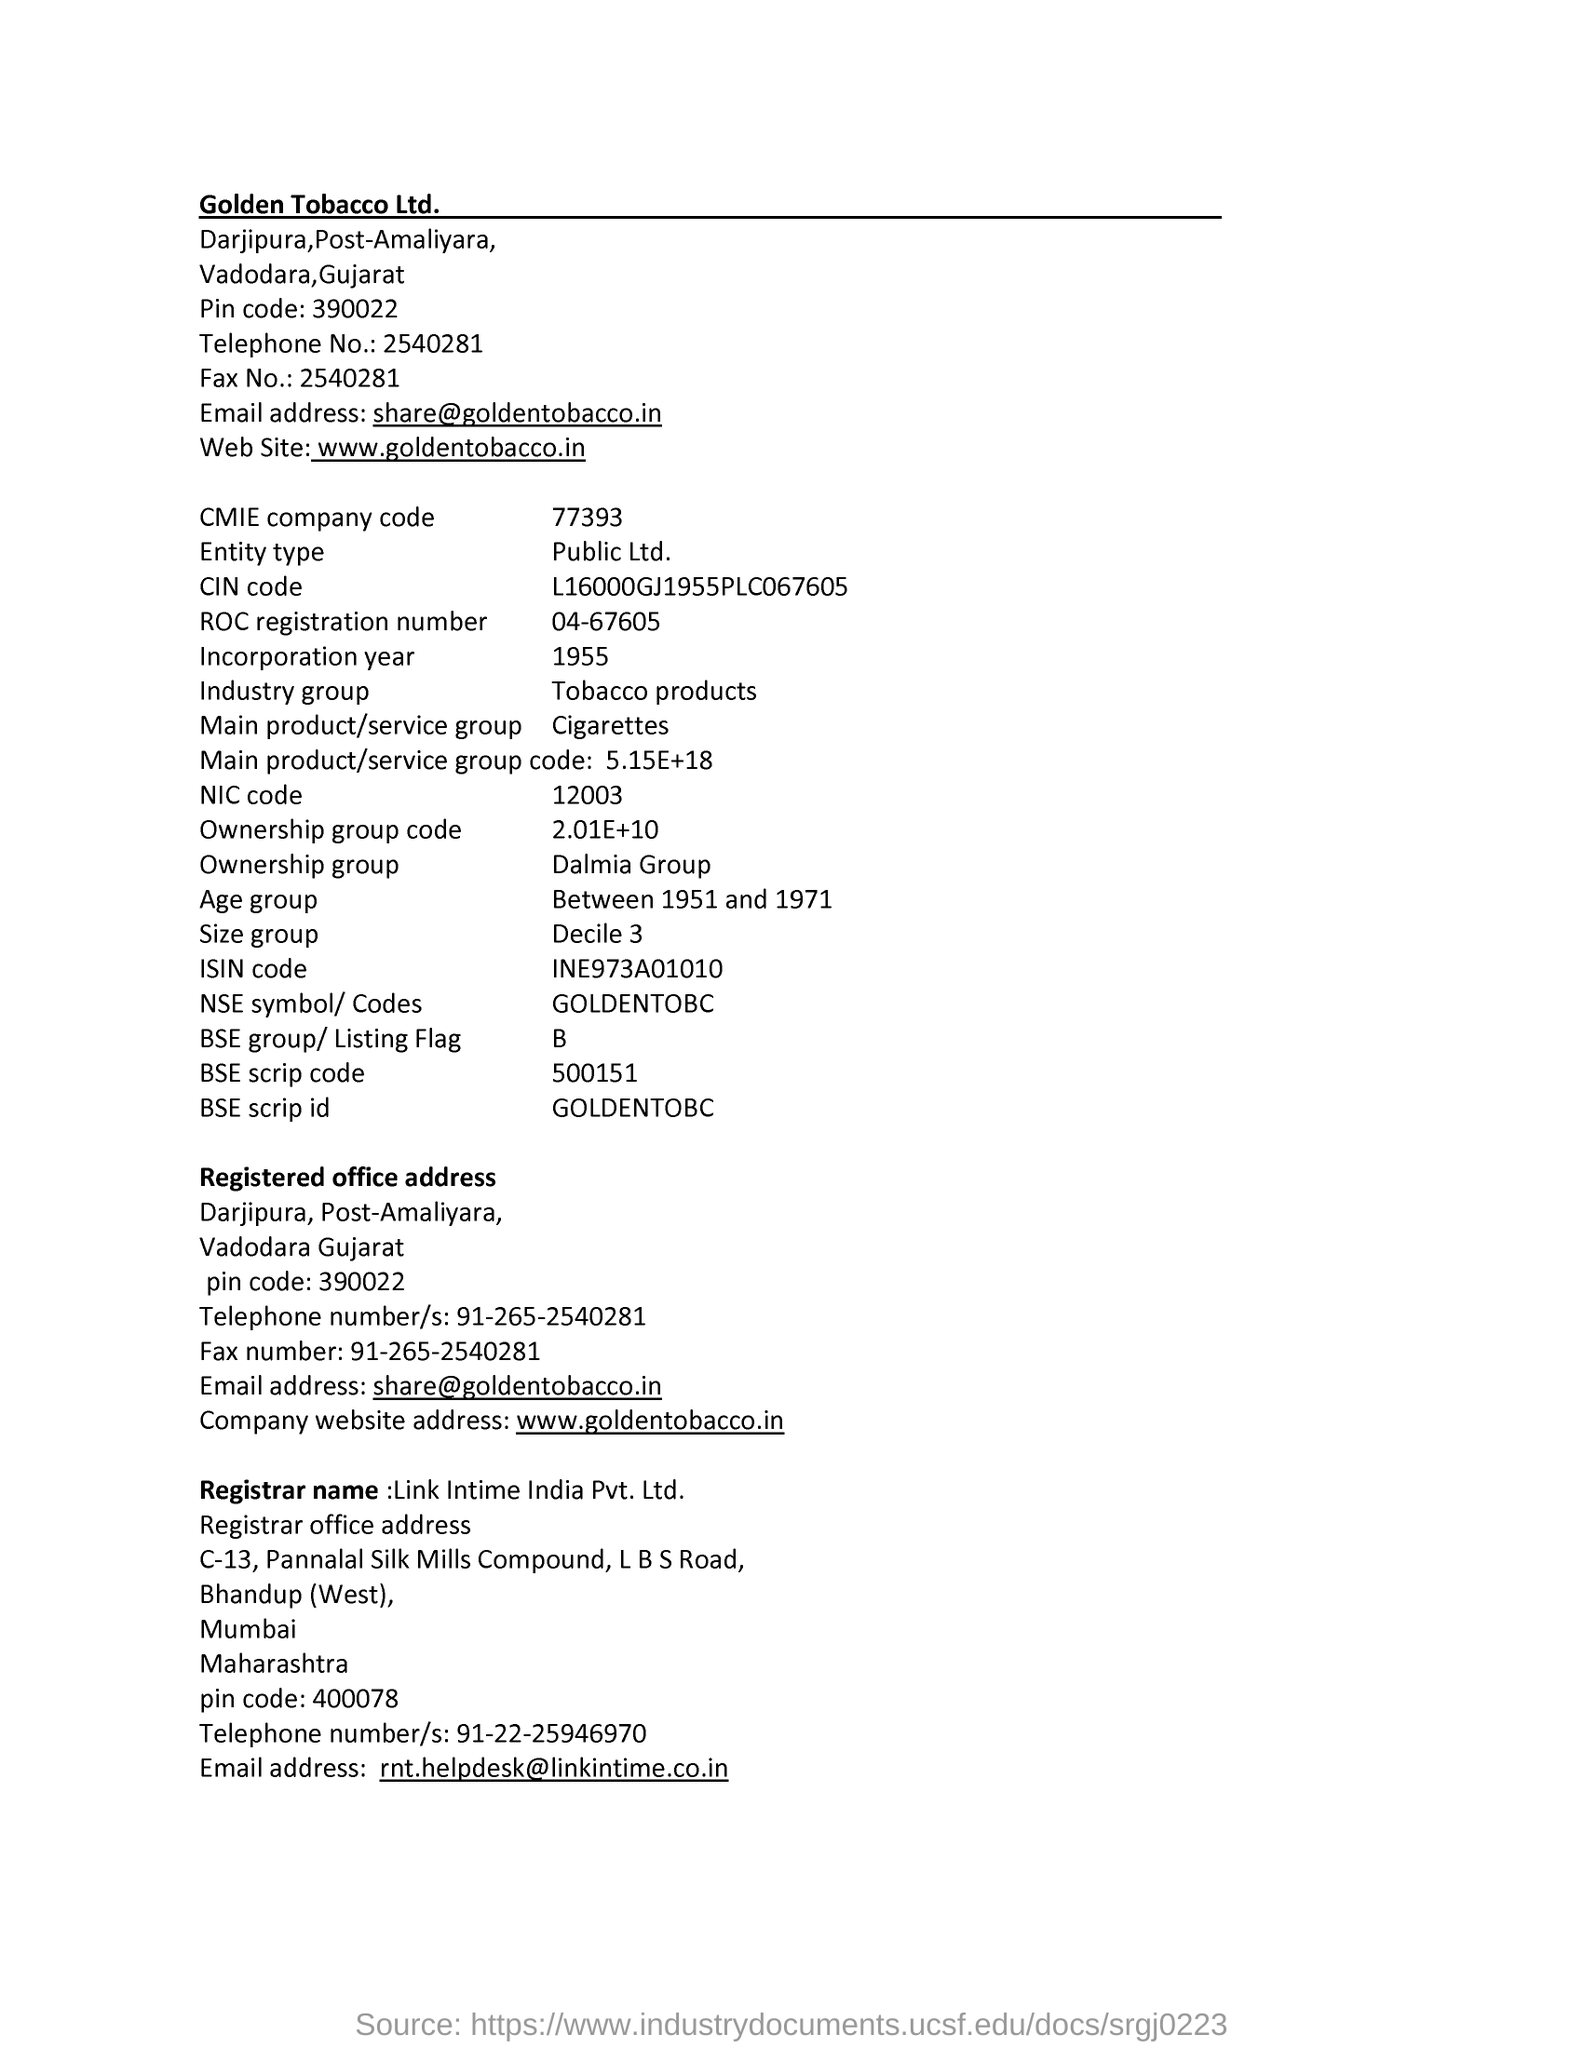Find incorporation year from this page?
Keep it short and to the point. 1955. What is entity type of company?
Offer a terse response. Public Ltd. What is CMIE company code?
Make the answer very short. 77393. Email ID of Golden Tobacco Company?
Keep it short and to the point. Share@goldentobacco.in. 